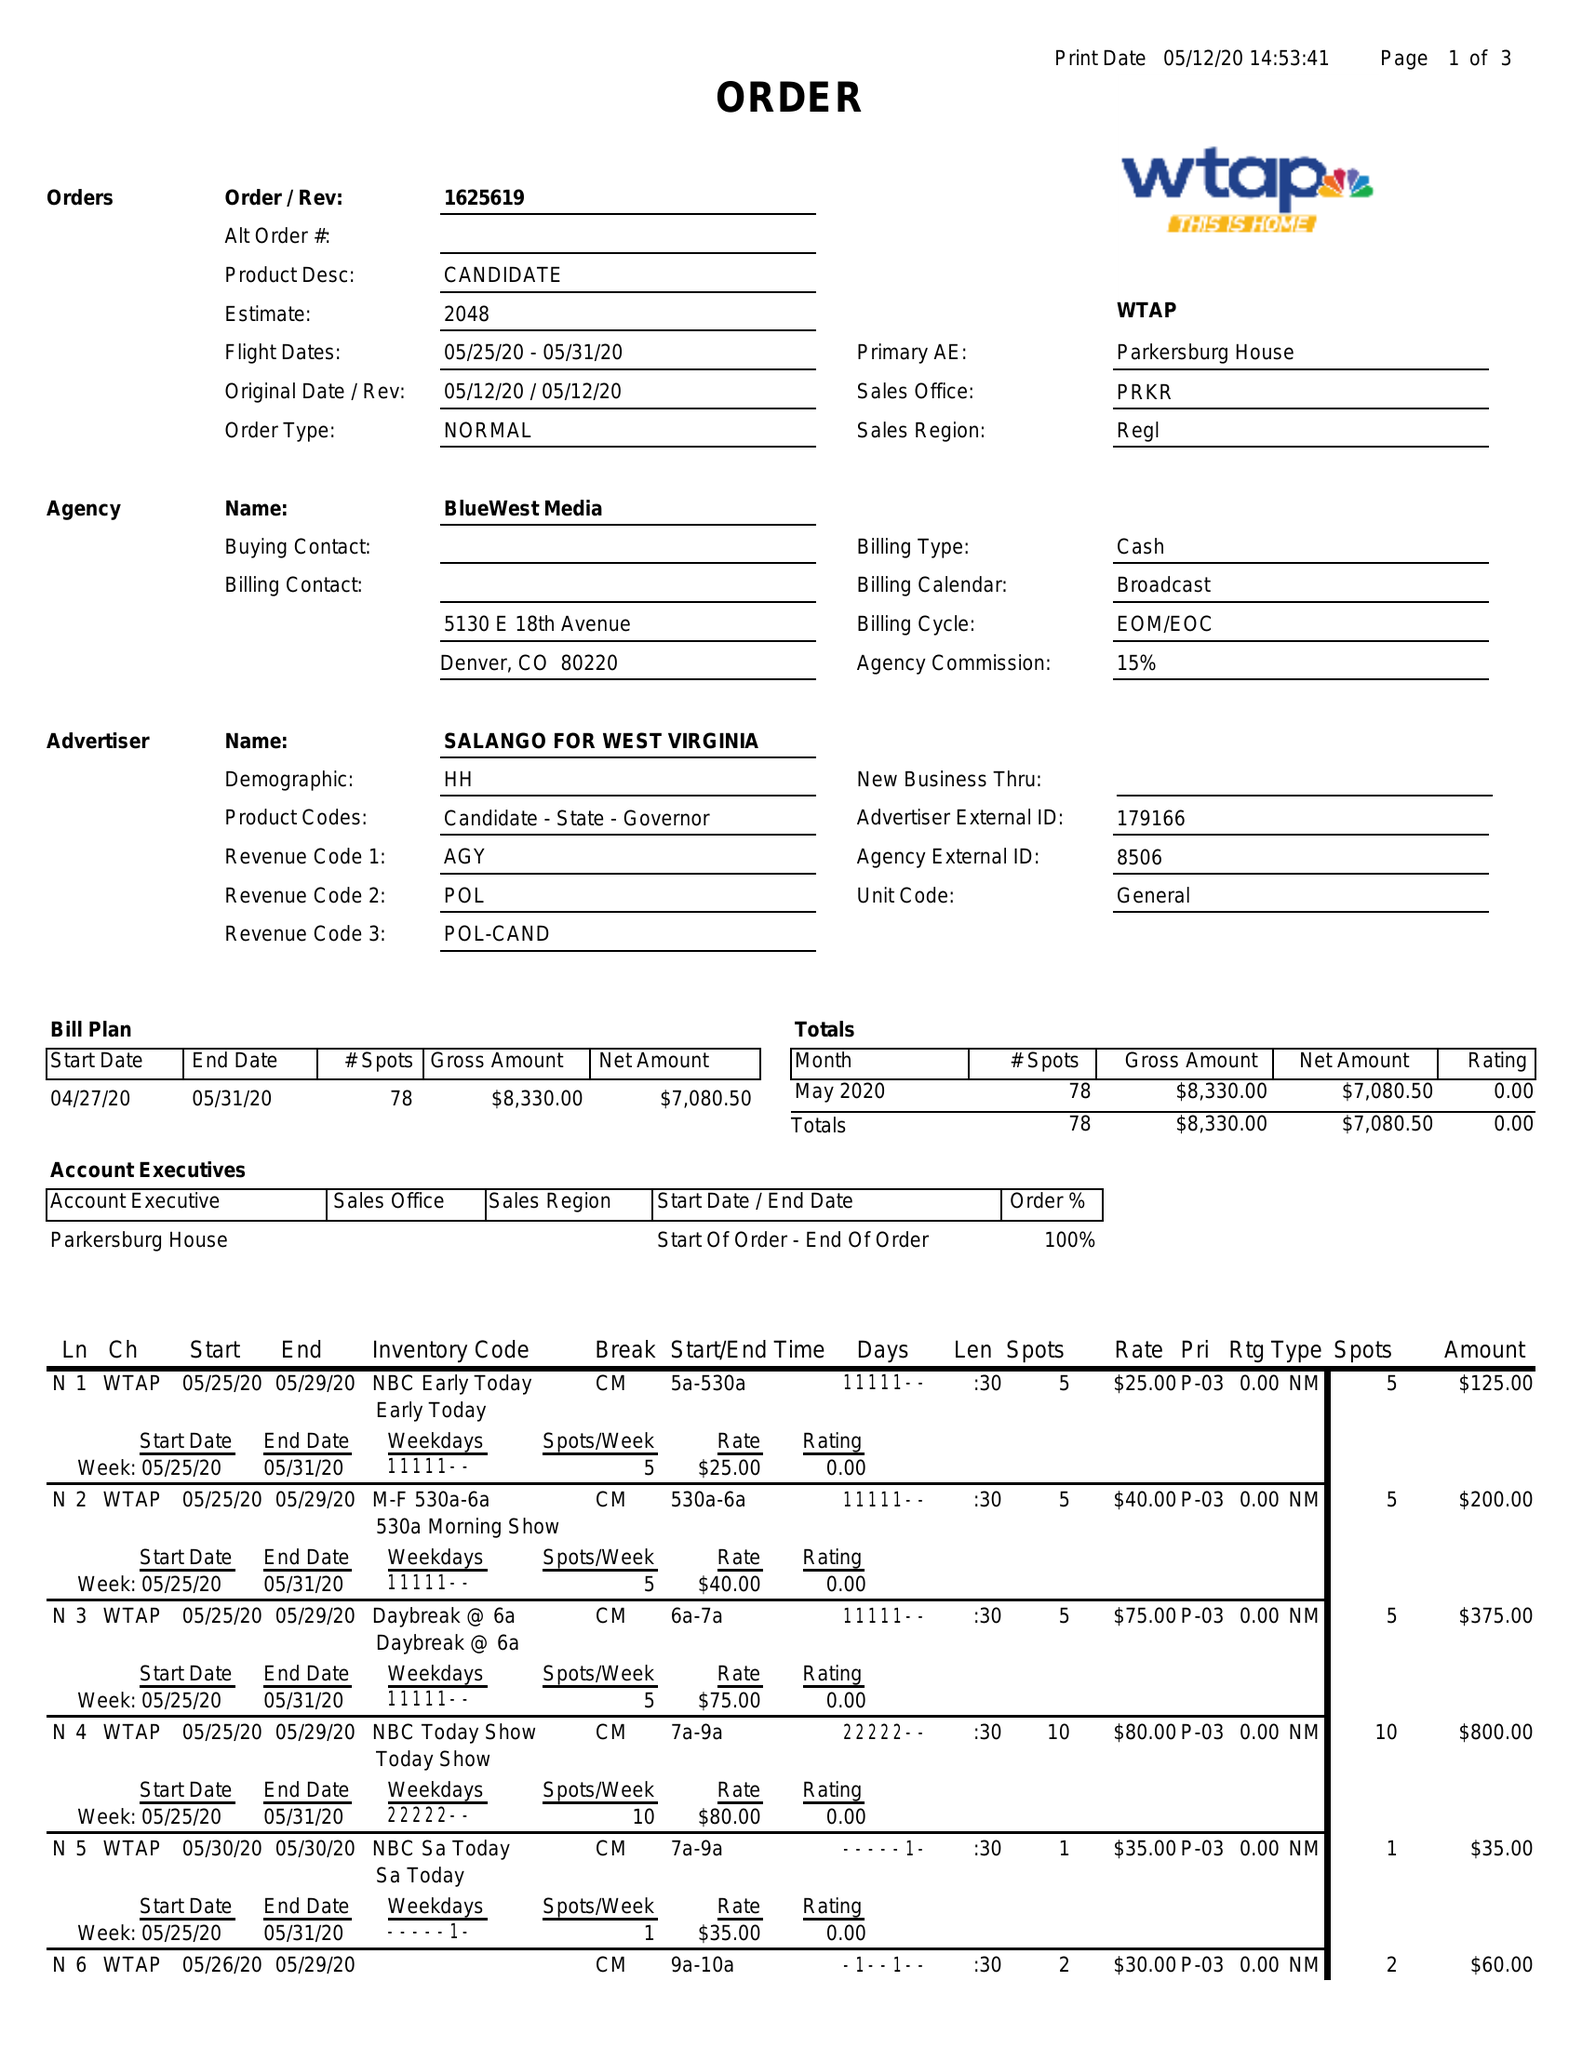What is the value for the flight_to?
Answer the question using a single word or phrase. 05/31/20 